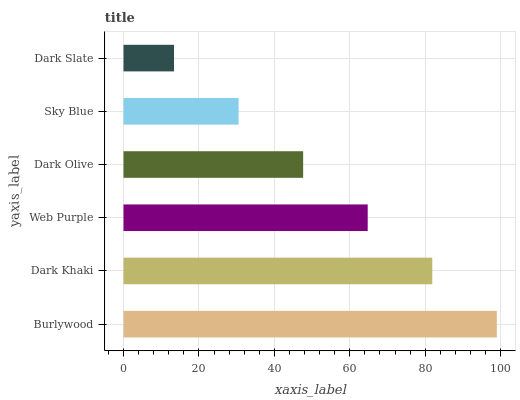Is Dark Slate the minimum?
Answer yes or no. Yes. Is Burlywood the maximum?
Answer yes or no. Yes. Is Dark Khaki the minimum?
Answer yes or no. No. Is Dark Khaki the maximum?
Answer yes or no. No. Is Burlywood greater than Dark Khaki?
Answer yes or no. Yes. Is Dark Khaki less than Burlywood?
Answer yes or no. Yes. Is Dark Khaki greater than Burlywood?
Answer yes or no. No. Is Burlywood less than Dark Khaki?
Answer yes or no. No. Is Web Purple the high median?
Answer yes or no. Yes. Is Dark Olive the low median?
Answer yes or no. Yes. Is Dark Khaki the high median?
Answer yes or no. No. Is Dark Khaki the low median?
Answer yes or no. No. 